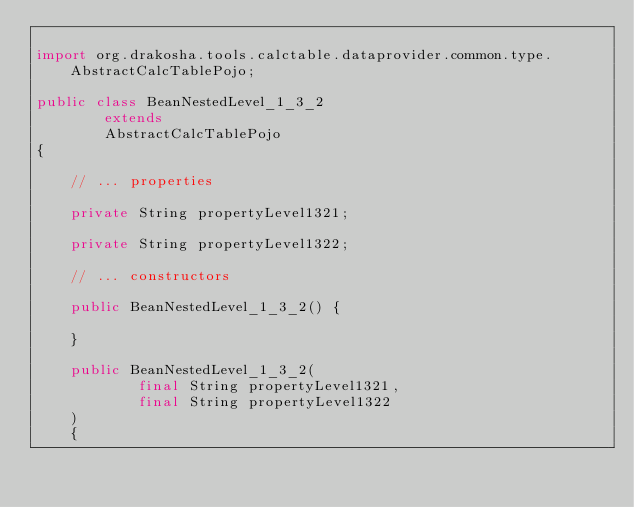Convert code to text. <code><loc_0><loc_0><loc_500><loc_500><_Java_>
import org.drakosha.tools.calctable.dataprovider.common.type.AbstractCalcTablePojo;

public class BeanNestedLevel_1_3_2
		extends
		AbstractCalcTablePojo
{

	// ... properties

	private String propertyLevel1321;

	private String propertyLevel1322;

	// ... constructors

	public BeanNestedLevel_1_3_2() {

	}

	public BeanNestedLevel_1_3_2(
			final String propertyLevel1321,
			final String propertyLevel1322
	)
	{
</code> 